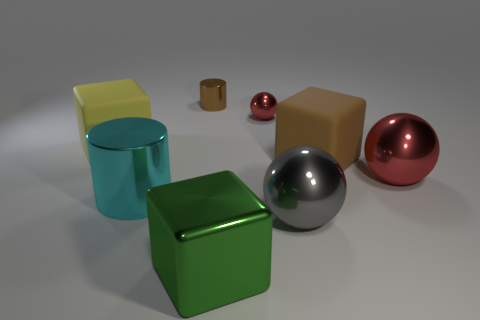Add 1 big purple metallic cubes. How many objects exist? 9 Subtract all cylinders. How many objects are left? 6 Add 4 large yellow objects. How many large yellow objects exist? 5 Subtract 1 gray balls. How many objects are left? 7 Subtract all yellow shiny objects. Subtract all large yellow matte blocks. How many objects are left? 7 Add 4 large yellow blocks. How many large yellow blocks are left? 5 